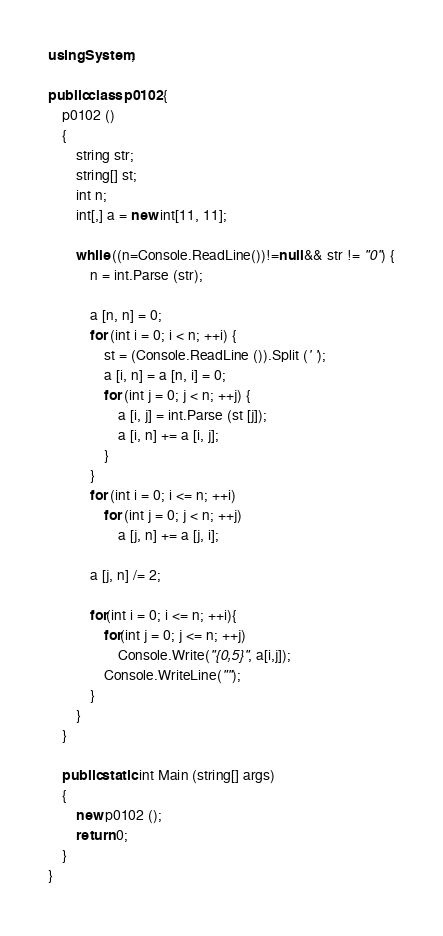<code> <loc_0><loc_0><loc_500><loc_500><_C#_>using System;

public class p0102{
	p0102 ()
	{
		string str;
		string[] st;
		int n;
		int[,] a = new int[11, 11];
		
		while ((n=Console.ReadLine())!=null && str != "0") {
			n = int.Parse (str);
			
			a [n, n] = 0;
			for (int i = 0; i < n; ++i) {
				st = (Console.ReadLine ()).Split (' ');
				a [i, n] = a [n, i] = 0;
				for (int j = 0; j < n; ++j) {
					a [i, j] = int.Parse (st [j]);
					a [i, n] += a [i, j];
				}
			}
			for (int i = 0; i <= n; ++i)
				for (int j = 0; j < n; ++j)
					a [j, n] += a [j, i];
			
			a [j, n] /= 2;
			
			for(int i = 0; i <= n; ++i){
				for(int j = 0; j <= n; ++j)
					Console.Write("{0,5}", a[i,j]);
				Console.WriteLine("");
			}
		}
	}
	
	public static int Main (string[] args)
	{
		new p0102 ();
		return 0;
	}
}</code> 